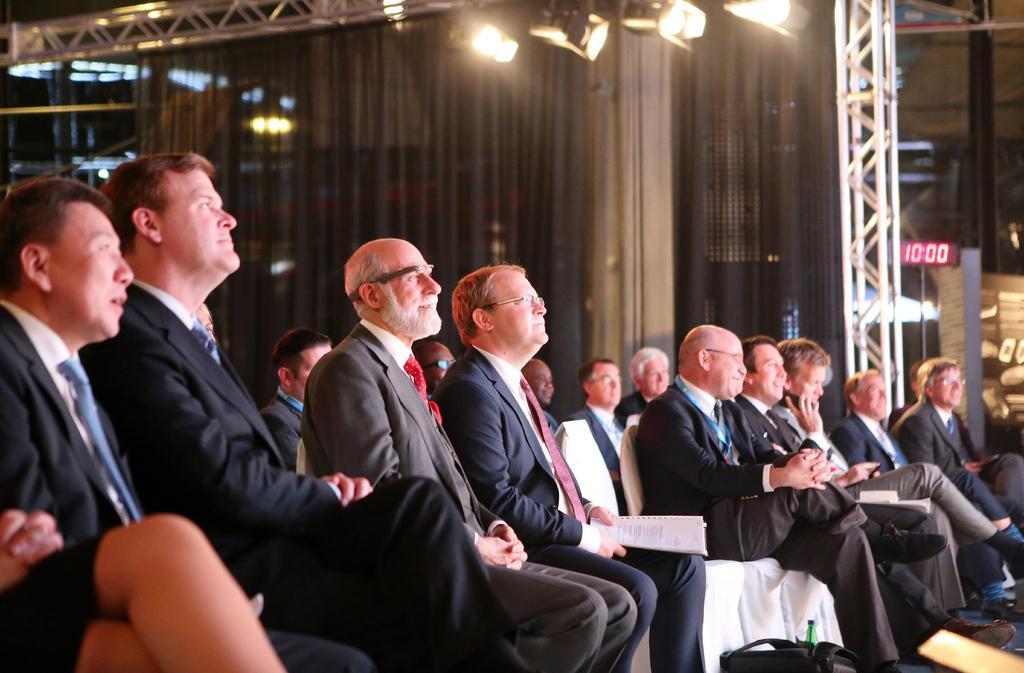Could you give a brief overview of what you see in this image? In this image there are chairs, people, bags in the foreground. There is a curtain in the background. There are lights on roof at the top 